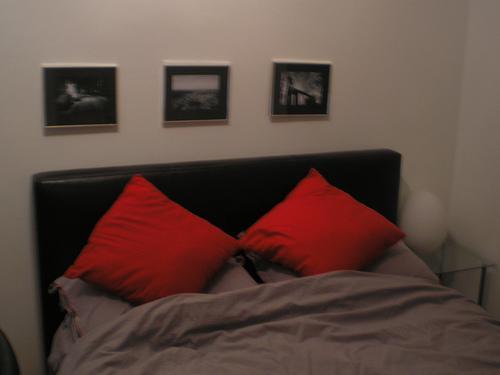How many photos are above the bed?
Give a very brief answer. 3. 